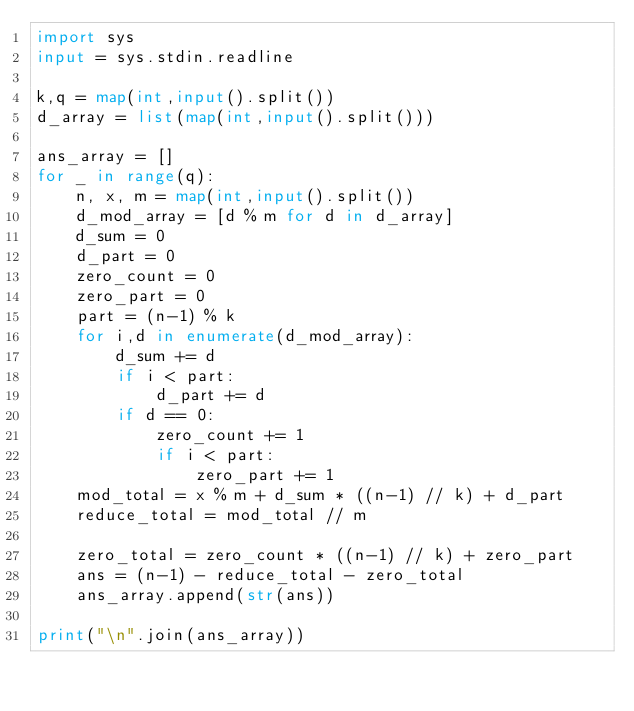<code> <loc_0><loc_0><loc_500><loc_500><_Python_>import sys
input = sys.stdin.readline

k,q = map(int,input().split())
d_array = list(map(int,input().split()))

ans_array = []
for _ in range(q):
    n, x, m = map(int,input().split())
    d_mod_array = [d % m for d in d_array]
    d_sum = 0
    d_part = 0
    zero_count = 0
    zero_part = 0
    part = (n-1) % k
    for i,d in enumerate(d_mod_array):
        d_sum += d
        if i < part:
            d_part += d
        if d == 0:
            zero_count += 1
            if i < part:
                zero_part += 1
    mod_total = x % m + d_sum * ((n-1) // k) + d_part
    reduce_total = mod_total // m

    zero_total = zero_count * ((n-1) // k) + zero_part
    ans = (n-1) - reduce_total - zero_total
    ans_array.append(str(ans))

print("\n".join(ans_array))

</code> 